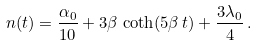<formula> <loc_0><loc_0><loc_500><loc_500>n ( t ) = \frac { \alpha _ { 0 } } { 1 0 } + 3 \beta \, \coth ( 5 \beta \, t ) + \frac { 3 \lambda _ { 0 } } { 4 } \, .</formula> 